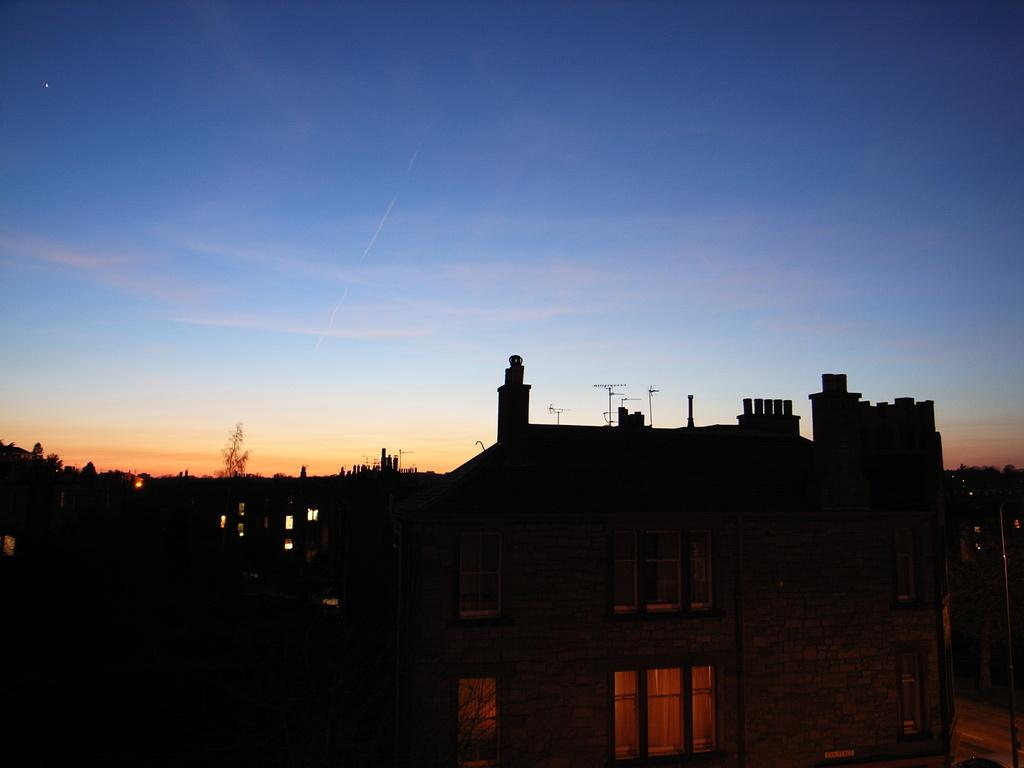What type of structures are present in the image? There are buildings in the image. What other natural elements can be seen in the image? There are trees in the image. What is visible in the background of the image? The sky is visible in the background of the image. What type of creature can be seen sniffing around the buildings in the image? There is no creature present in the image; it only features buildings, trees, and the sky. How many wrists are visible in the image? There are no wrists visible in the image, as it does not depict any people or body parts. 